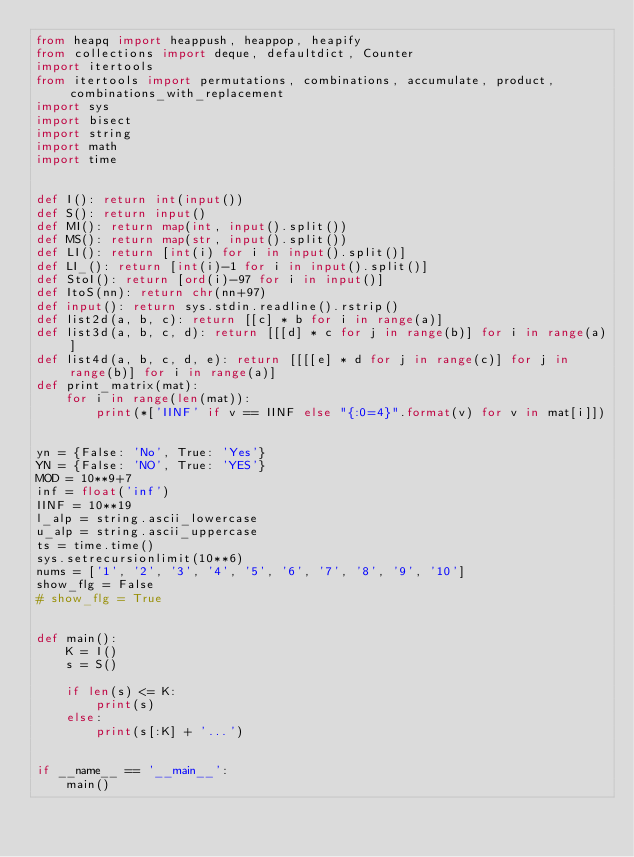<code> <loc_0><loc_0><loc_500><loc_500><_Python_>from heapq import heappush, heappop, heapify
from collections import deque, defaultdict, Counter
import itertools
from itertools import permutations, combinations, accumulate, product, combinations_with_replacement
import sys
import bisect
import string
import math
import time


def I(): return int(input())
def S(): return input()
def MI(): return map(int, input().split())
def MS(): return map(str, input().split())
def LI(): return [int(i) for i in input().split()]
def LI_(): return [int(i)-1 for i in input().split()]
def StoI(): return [ord(i)-97 for i in input()]
def ItoS(nn): return chr(nn+97)
def input(): return sys.stdin.readline().rstrip()
def list2d(a, b, c): return [[c] * b for i in range(a)]
def list3d(a, b, c, d): return [[[d] * c for j in range(b)] for i in range(a)]
def list4d(a, b, c, d, e): return [[[[e] * d for j in range(c)] for j in range(b)] for i in range(a)]
def print_matrix(mat):
    for i in range(len(mat)):
        print(*['IINF' if v == IINF else "{:0=4}".format(v) for v in mat[i]])


yn = {False: 'No', True: 'Yes'}
YN = {False: 'NO', True: 'YES'}
MOD = 10**9+7
inf = float('inf')
IINF = 10**19
l_alp = string.ascii_lowercase
u_alp = string.ascii_uppercase
ts = time.time()
sys.setrecursionlimit(10**6)
nums = ['1', '2', '3', '4', '5', '6', '7', '8', '9', '10']
show_flg = False
# show_flg = True


def main():
    K = I()
    s = S()

    if len(s) <= K:
        print(s)
    else:
        print(s[:K] + '...')


if __name__ == '__main__':
    main()
</code> 